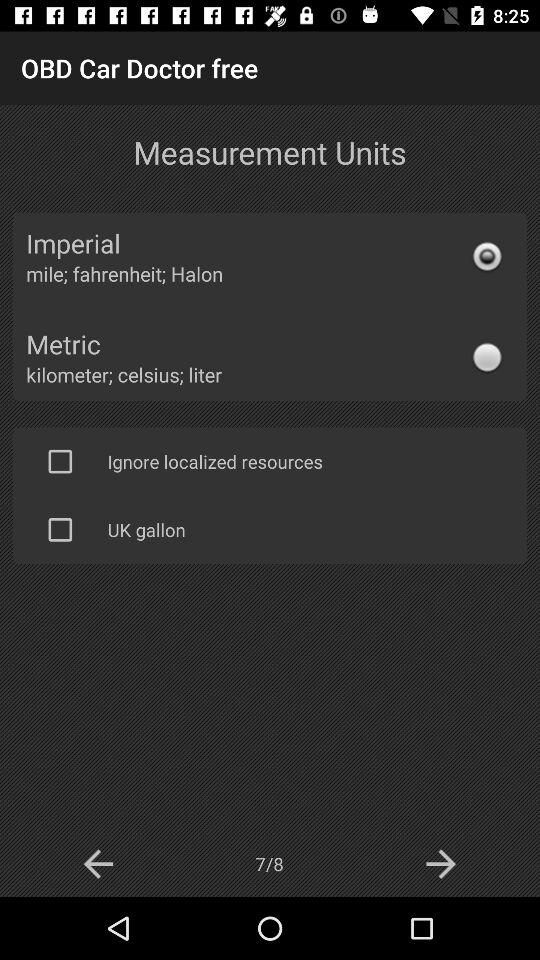Which page are we currently on? You are currently on page 7. 